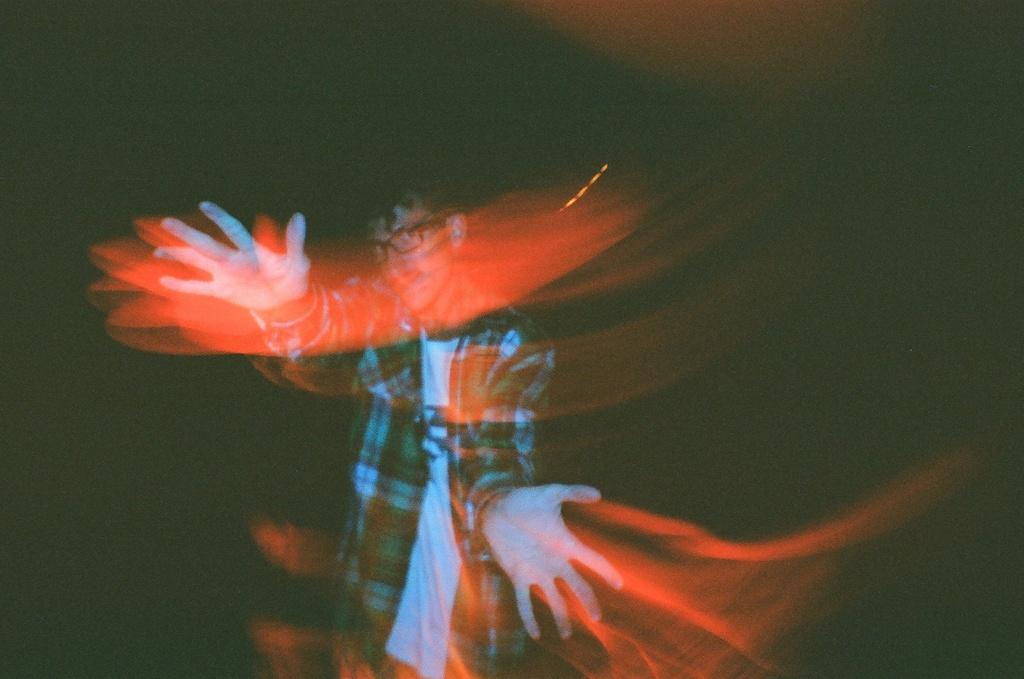How would you summarize this image in a sentence or two? In this image I can see a person standing and wearing different color dress. Background is in black and red color. 